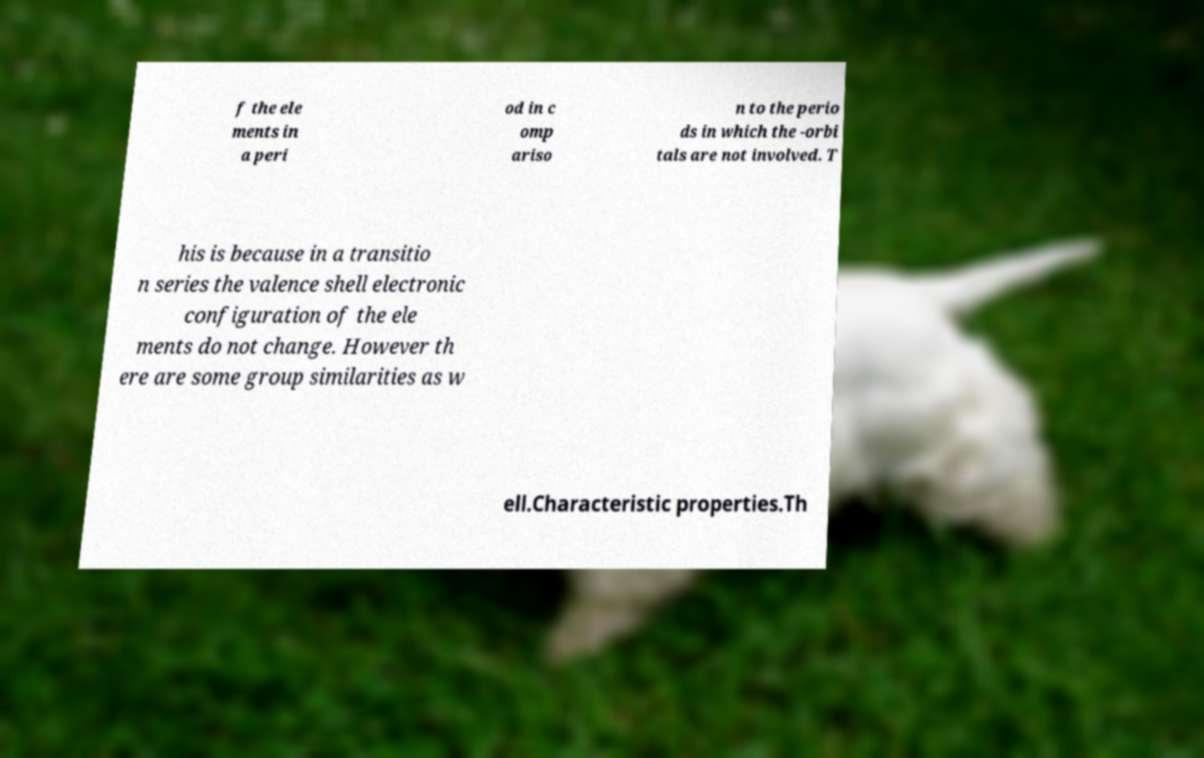What messages or text are displayed in this image? I need them in a readable, typed format. f the ele ments in a peri od in c omp ariso n to the perio ds in which the -orbi tals are not involved. T his is because in a transitio n series the valence shell electronic configuration of the ele ments do not change. However th ere are some group similarities as w ell.Characteristic properties.Th 